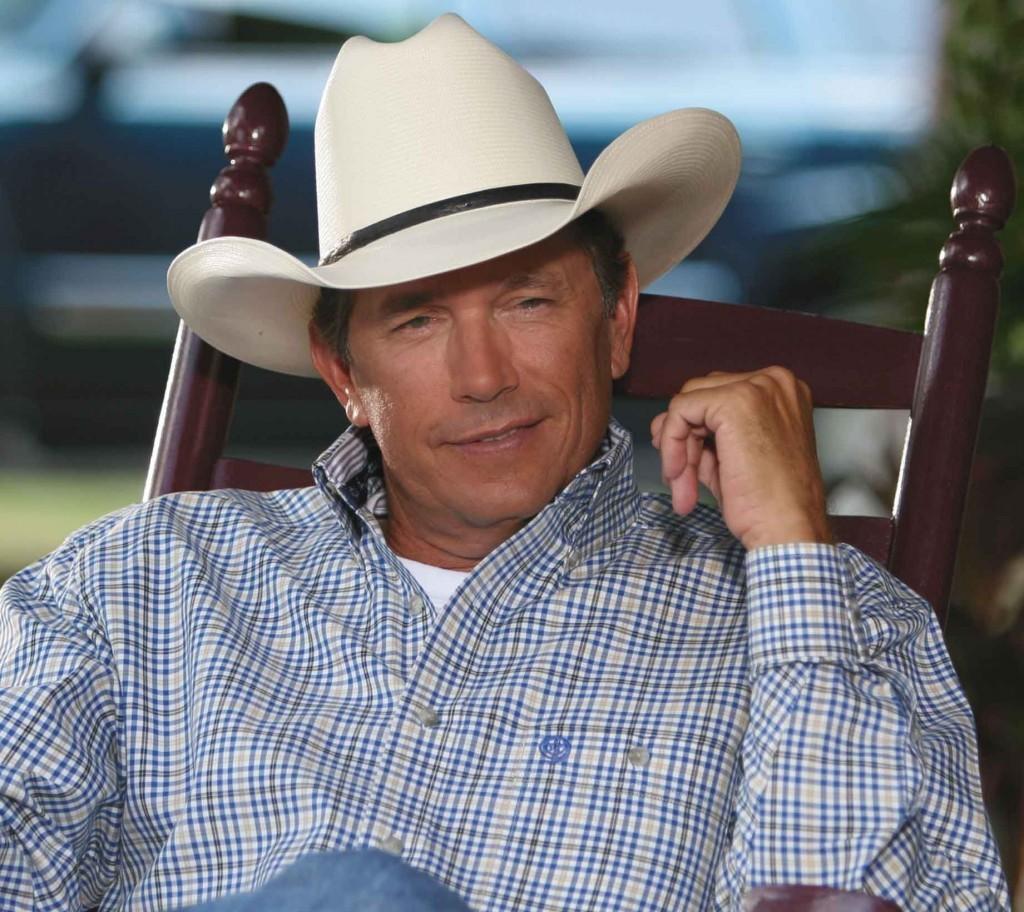Can you describe this image briefly? In this image I can see a man. He is sitting on the chair. He is wearing a hat. 